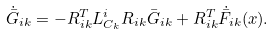Convert formula to latex. <formula><loc_0><loc_0><loc_500><loc_500>\dot { \bar { G } } _ { i k } = - R _ { i k } ^ { T } L _ { C _ { k } } ^ { i } R _ { i k } \bar { G } _ { i k } + R _ { i k } ^ { T } \dot { \bar { F } } _ { i k } ( x ) .</formula> 